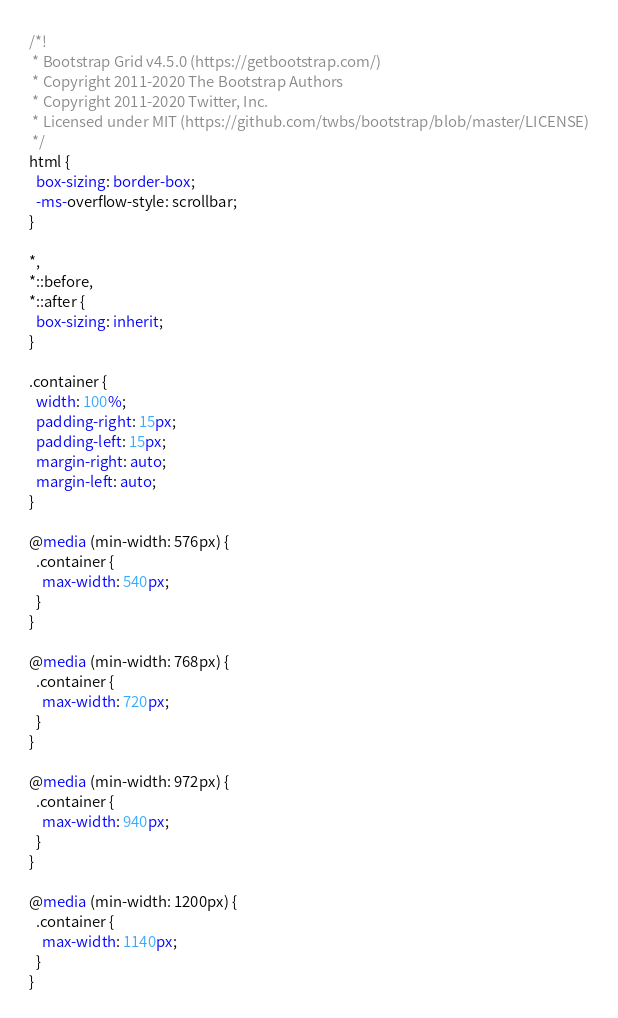Convert code to text. <code><loc_0><loc_0><loc_500><loc_500><_CSS_>/*!
 * Bootstrap Grid v4.5.0 (https://getbootstrap.com/)
 * Copyright 2011-2020 The Bootstrap Authors
 * Copyright 2011-2020 Twitter, Inc.
 * Licensed under MIT (https://github.com/twbs/bootstrap/blob/master/LICENSE)
 */
html {
  box-sizing: border-box;
  -ms-overflow-style: scrollbar;
}

*,
*::before,
*::after {
  box-sizing: inherit;
}

.container {
  width: 100%;
  padding-right: 15px;
  padding-left: 15px;
  margin-right: auto;
  margin-left: auto;
}

@media (min-width: 576px) {
  .container {
    max-width: 540px;
  }
}

@media (min-width: 768px) {
  .container {
    max-width: 720px;
  }
}

@media (min-width: 972px) {
  .container {
    max-width: 940px;
  }
}

@media (min-width: 1200px) {
  .container {
    max-width: 1140px;
  }
}
</code> 